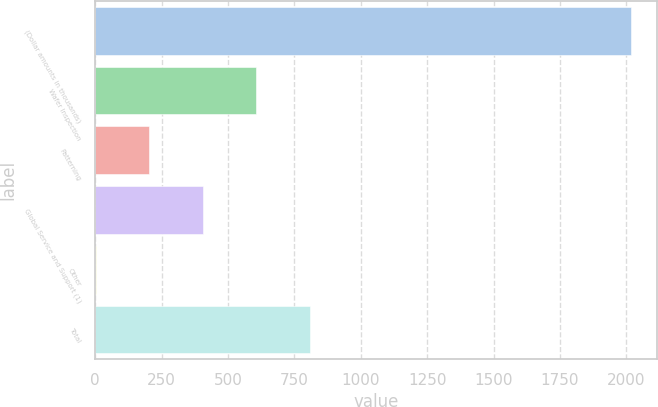Convert chart. <chart><loc_0><loc_0><loc_500><loc_500><bar_chart><fcel>(Dollar amounts in thousands)<fcel>Wafer Inspection<fcel>Patterning<fcel>Global Service and Support (1)<fcel>Other<fcel>Total<nl><fcel>2016<fcel>606.2<fcel>203.4<fcel>404.8<fcel>2<fcel>807.6<nl></chart> 